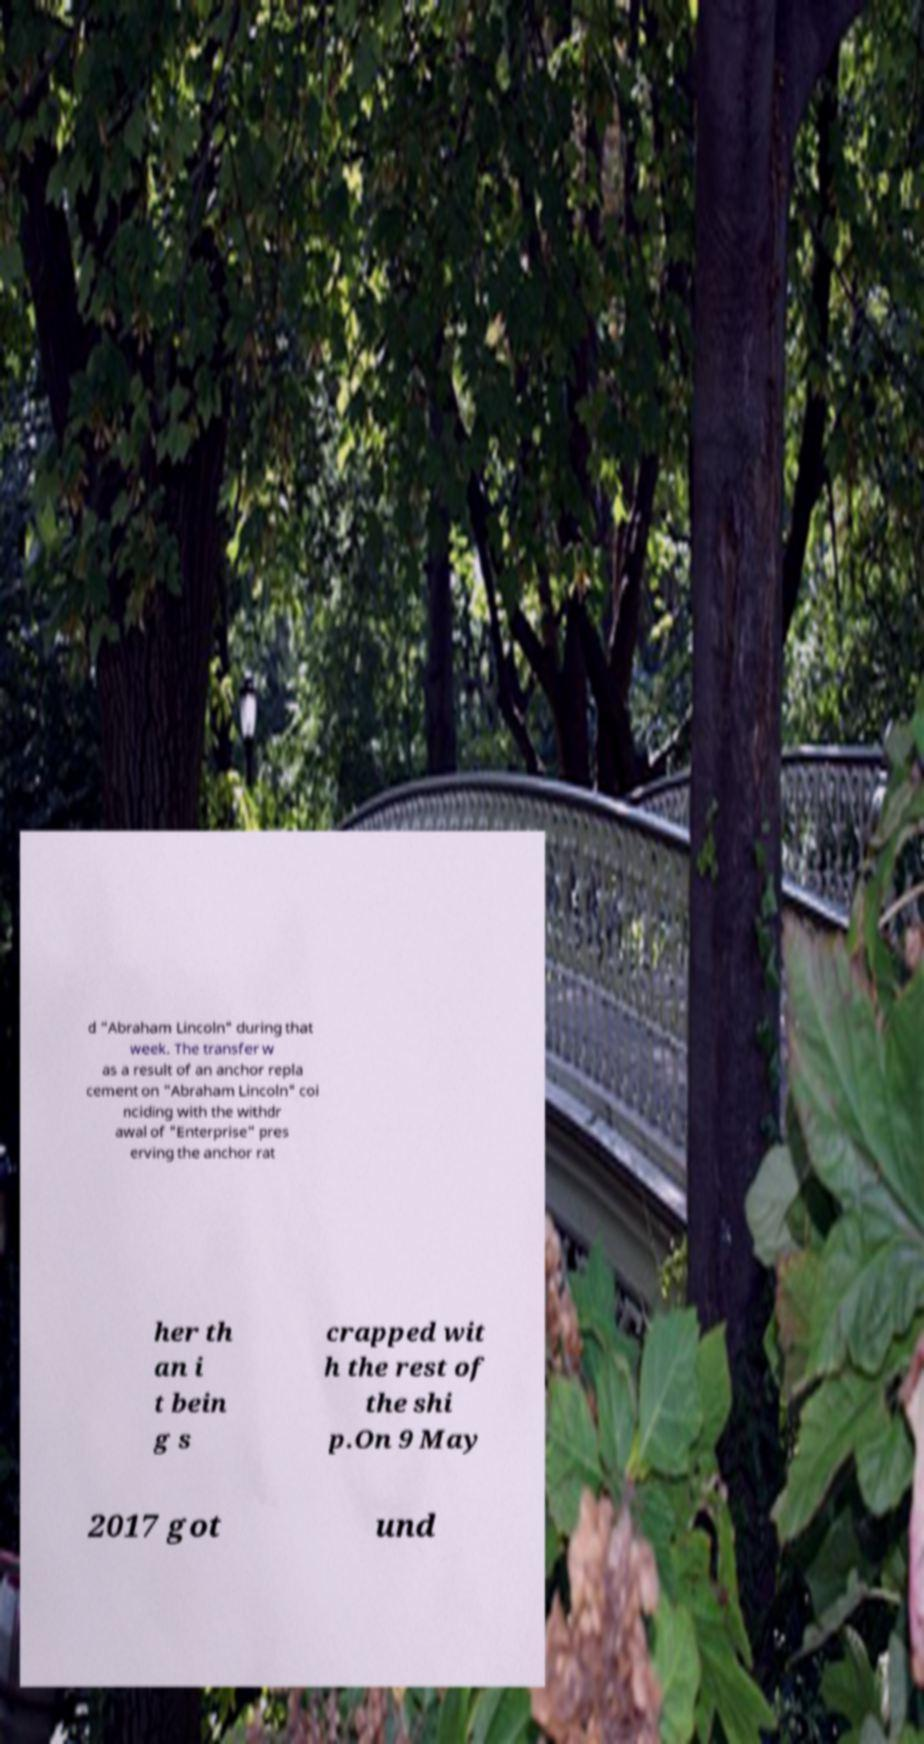Can you accurately transcribe the text from the provided image for me? d "Abraham Lincoln" during that week. The transfer w as a result of an anchor repla cement on "Abraham Lincoln" coi nciding with the withdr awal of "Enterprise" pres erving the anchor rat her th an i t bein g s crapped wit h the rest of the shi p.On 9 May 2017 got und 